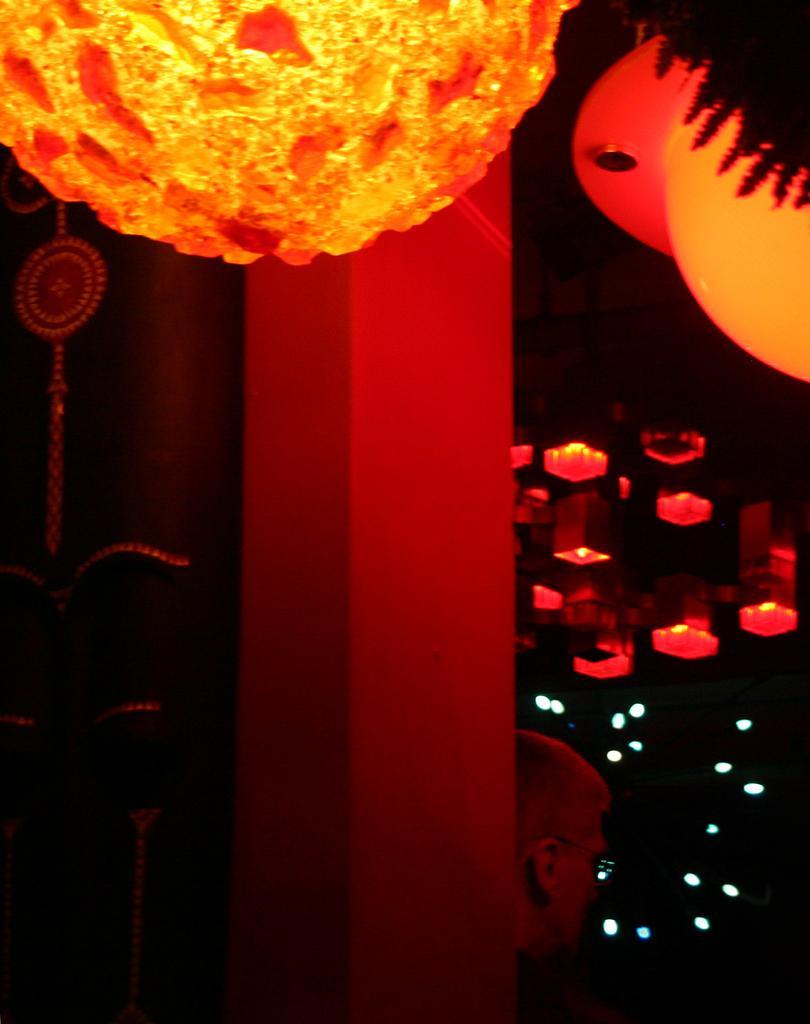Could you give a brief overview of what you see in this image? In the image I can see a person and some lights and lamps to the roof. 